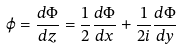Convert formula to latex. <formula><loc_0><loc_0><loc_500><loc_500>\varphi = \frac { d \Phi } { d z } = \frac { 1 } { 2 } \frac { d \Phi } { d x } + \frac { 1 } { 2 i } \frac { d \Phi } { d y }</formula> 